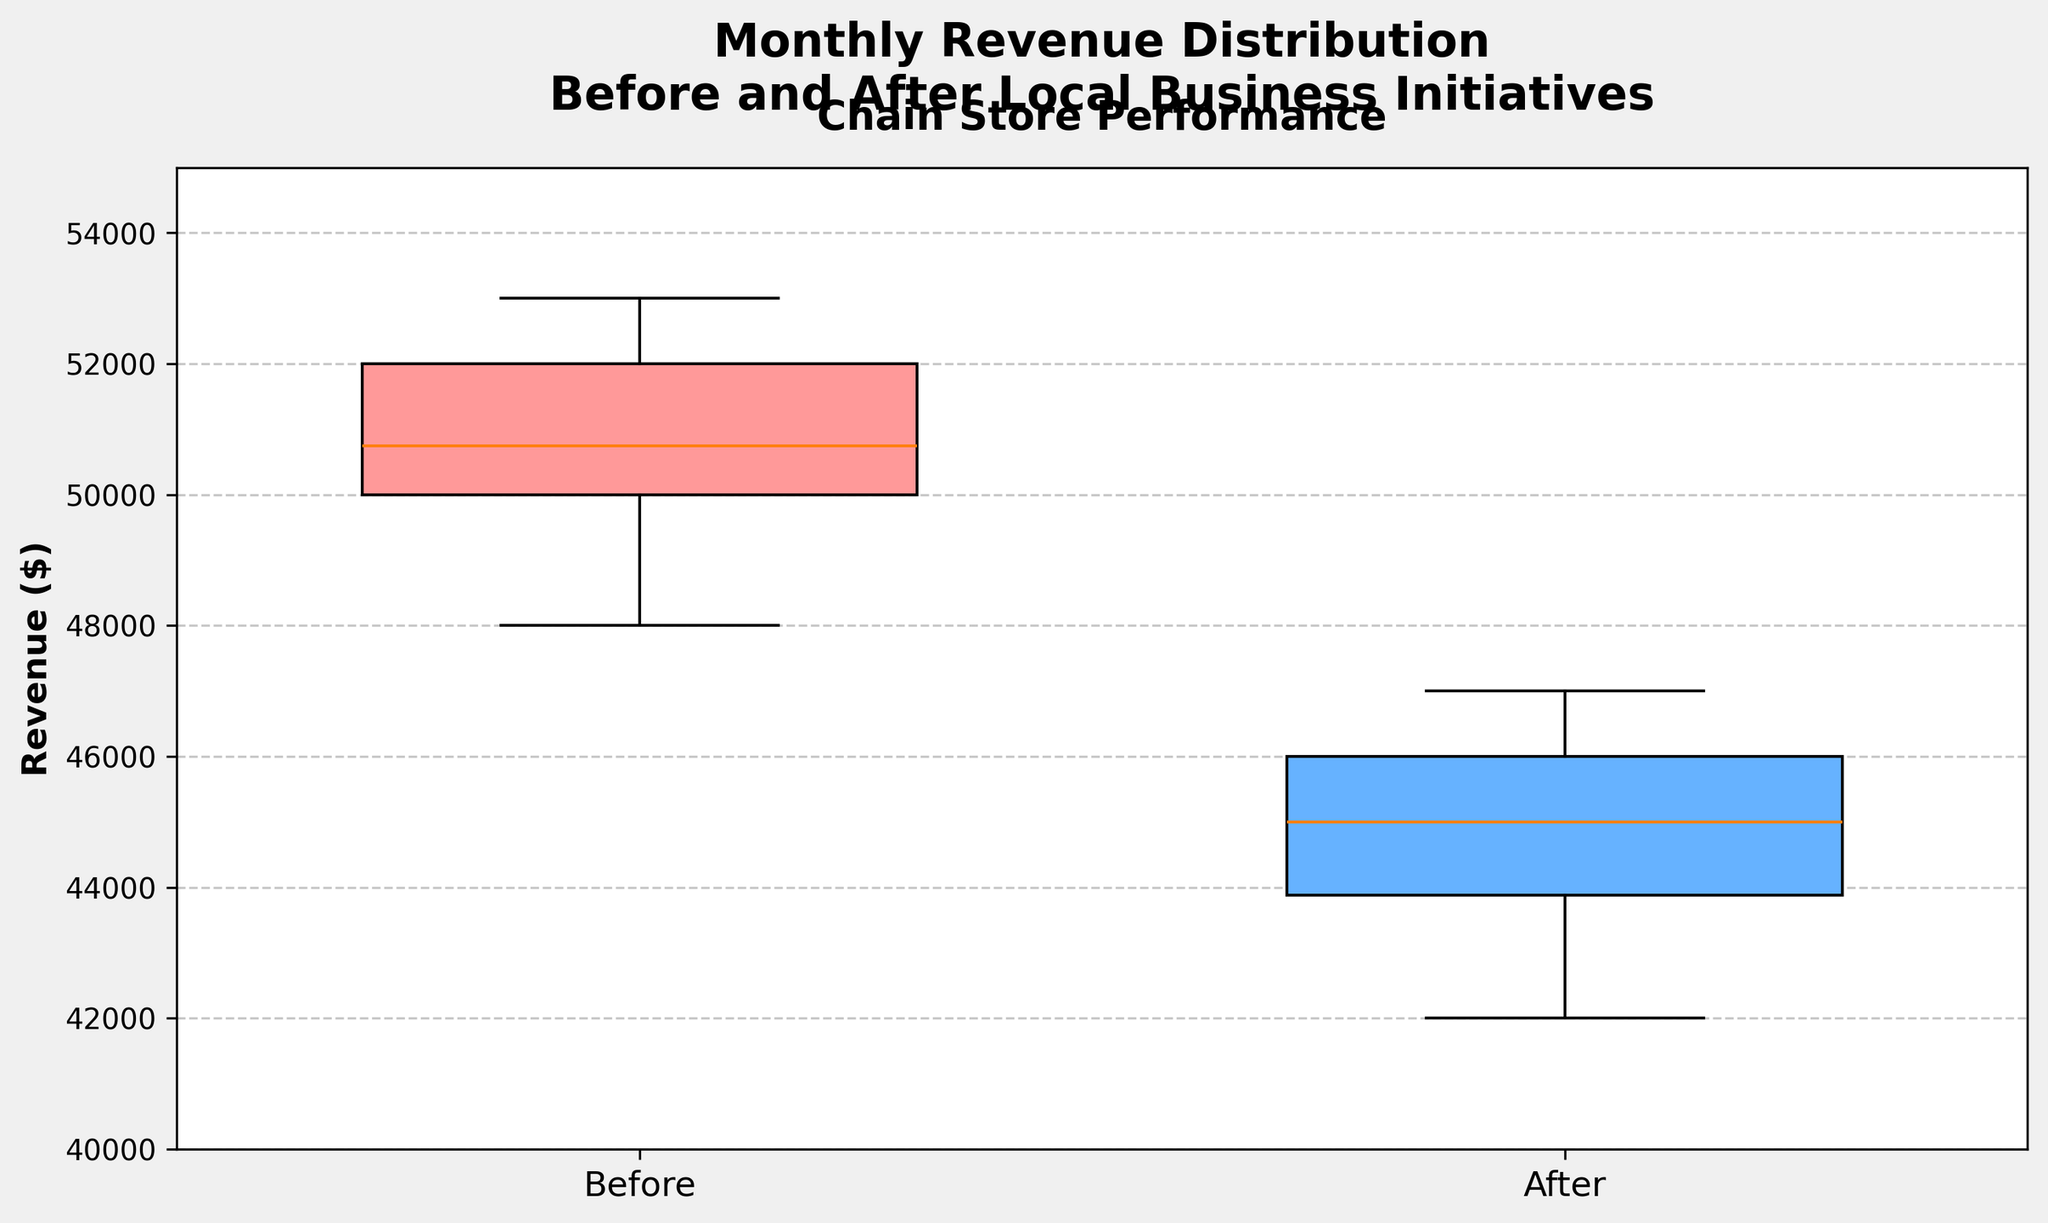What are the titles of the x-axis categories? The x-axis categories are labeled to compare the revenue before and after the local business initiatives. The x-axis in the box plot has two distinct labels.
Answer: Before and After What is the y-axis range in the box plot? The y-axis range is visible through the set minimum and maximum tick marks on the y-axis.
Answer: 40000 to 55000 What are the median monthly revenues before and after the local business initiatives? Observe the median lines within each box in the box plot. The median is the line inside the box.
Answer: Before: ~50500, After: ~45000 Which group shows a greater variability in monthly revenue? Variability can be assessed by the length of the box and the whiskers. The longer the box and whiskers, the higher the variability.
Answer: Before By how much did the median monthly revenue change after the local business initiatives? The median for "Before" the initiatives is approximately 50500 and for "After" is approximately 45000. The change in median is the difference between these two values.
Answer: ~5500 decrease What were the minimum and maximum monthly revenues before the local business initiatives took place? The minimum and maximum values can be determined by the endpoints of the whiskers in the 'Before' box plot.
Answer: Minimum: 48000, Maximum: 53000 Is there any overlap in the interquartile ranges of the revenues before and after the initiatives? Overlap in interquartile ranges can be assessed by looking at the bottom and top of the boxes; if they intersect, there is an overlap.
Answer: No What is the interquartile range (IQR) for the revenue after the local business initiatives? The interquartile range (IQR) is the difference between the third quartile (upper edge of the box) and the first quartile (lower edge of the box).
Answer: ~3500 Which month has the highest monthly revenue after the initiatives, according to the box plot? The outliers or whiskers do not indicate specific months, so conclusions about individual months can't be drawn from the box plot. Use table data.
Answer: December and September Has the general trend in monthly revenues improved or declined after the local business initiatives? Examine the medians and the overall position of boxes to determine the direction of change in revenues.
Answer: Declined 